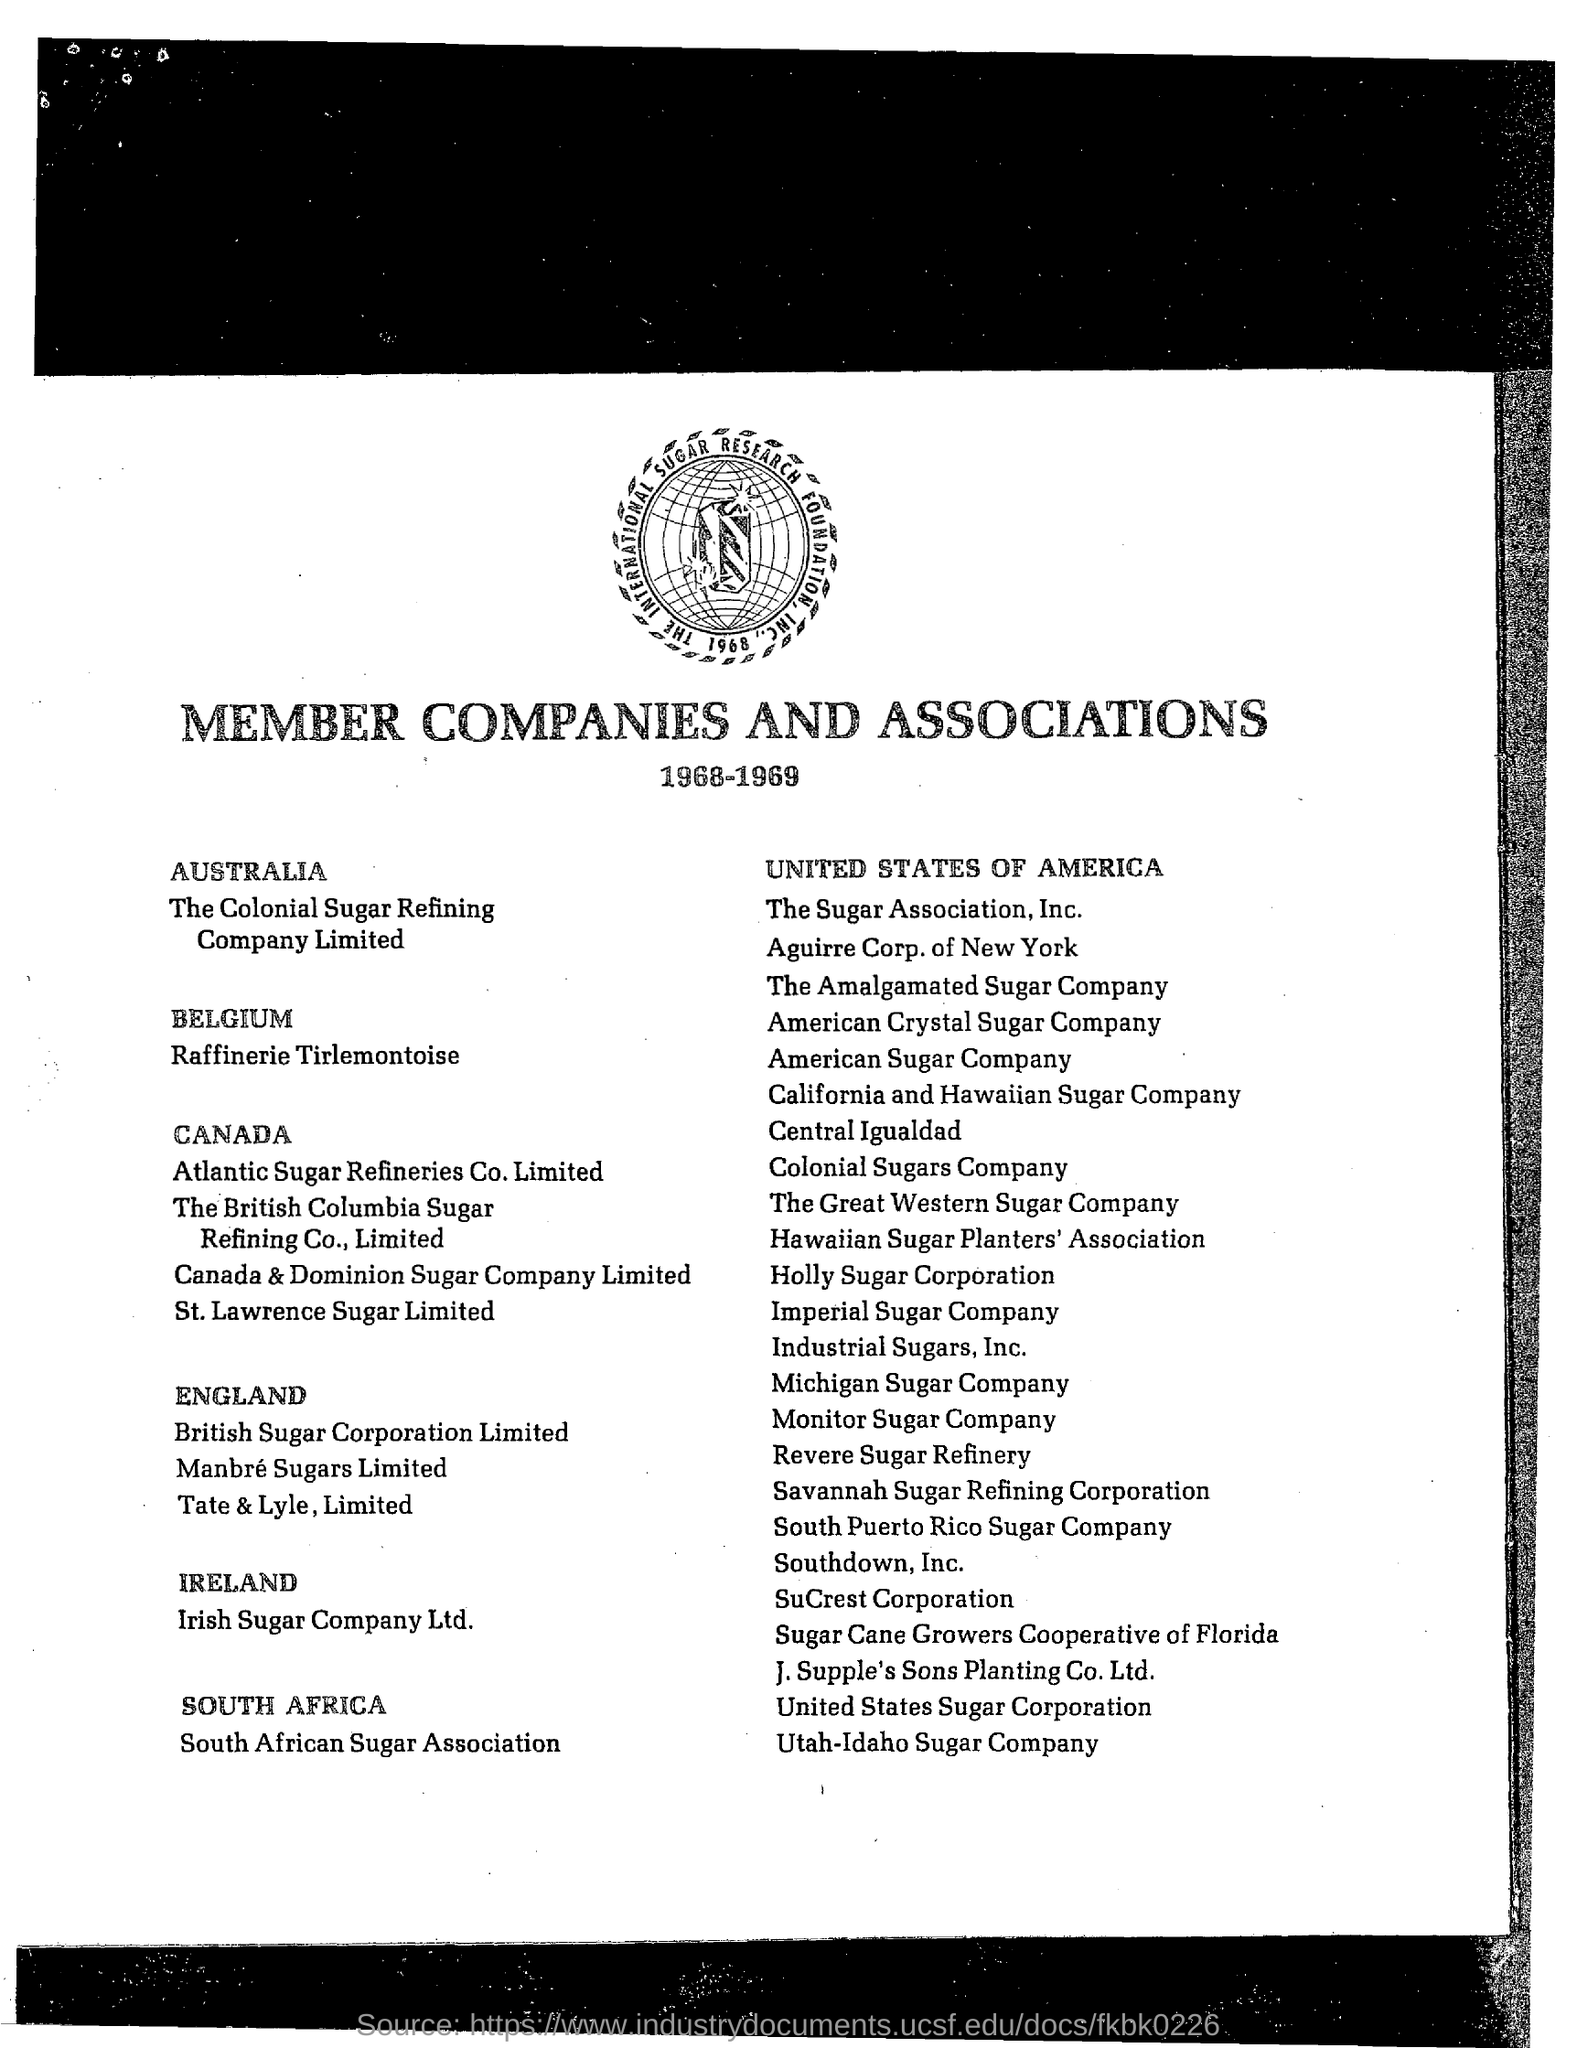Outline some significant characteristics in this image. The Irish Sugar Company Ltd. is a company located in Ireland. The association that is mentioned is Member Companies and Associations. The Colonial Sugar Refining Company Limited is a member company in Australia. The Utah-Idaho Sugar Company is located in the United States of America. 